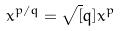<formula> <loc_0><loc_0><loc_500><loc_500>x ^ { p / q } = \sqrt { [ } q ] { x ^ { p } }</formula> 